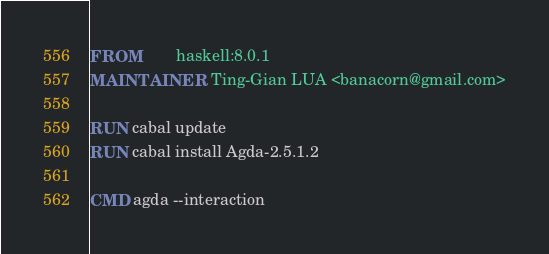<code> <loc_0><loc_0><loc_500><loc_500><_Dockerfile_>FROM        haskell:8.0.1
MAINTAINER  Ting-Gian LUA <banacorn@gmail.com>

RUN cabal update
RUN cabal install Agda-2.5.1.2

CMD agda --interaction
</code> 